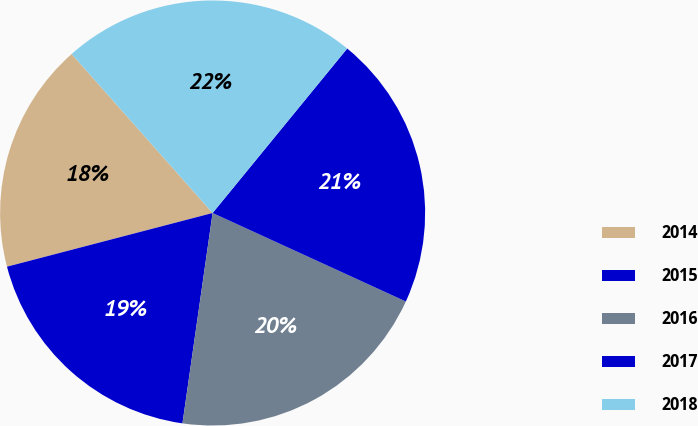<chart> <loc_0><loc_0><loc_500><loc_500><pie_chart><fcel>2014<fcel>2015<fcel>2016<fcel>2017<fcel>2018<nl><fcel>17.52%<fcel>18.67%<fcel>20.43%<fcel>20.92%<fcel>22.46%<nl></chart> 